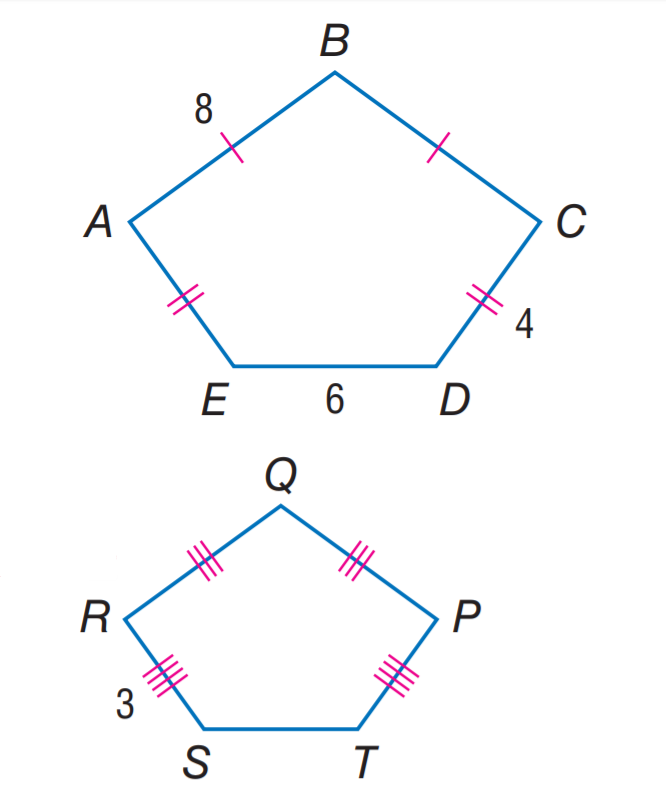Answer the mathemtical geometry problem and directly provide the correct option letter.
Question: If A B C D E \sim P Q R S T, find the perimeter of P Q R S T.
Choices: A: 22.5 B: 25 C: 27.5 D: 30 A 